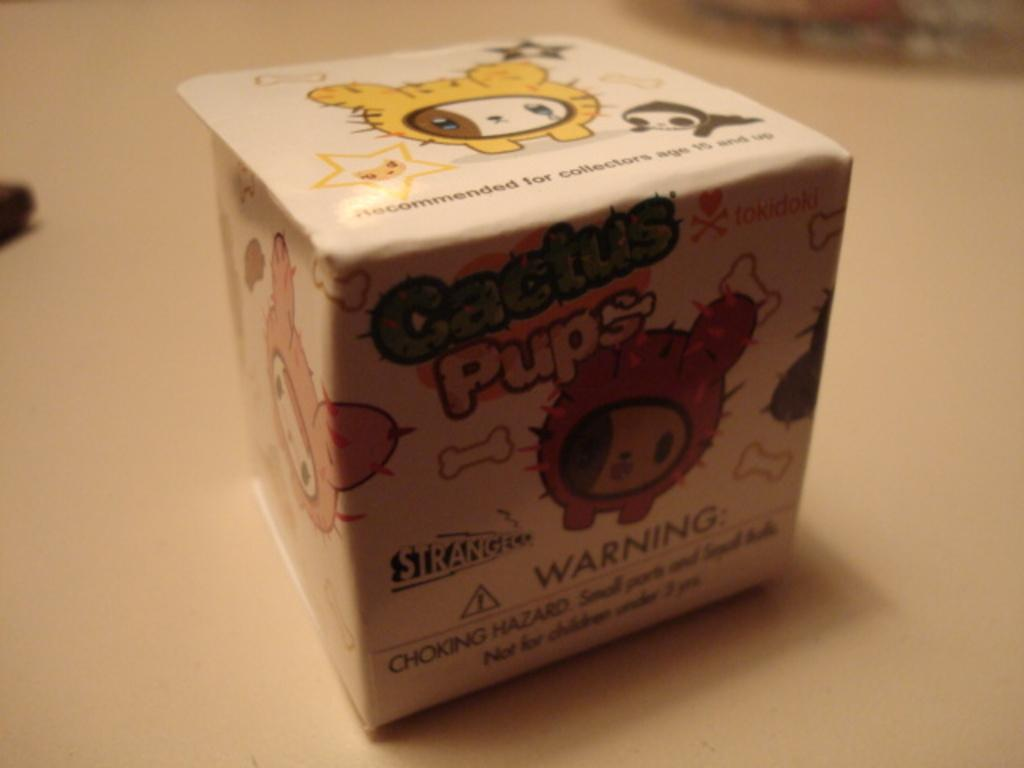<image>
Relay a brief, clear account of the picture shown. A white box with cartoon art of Cactus Pups from StrangeCo. 